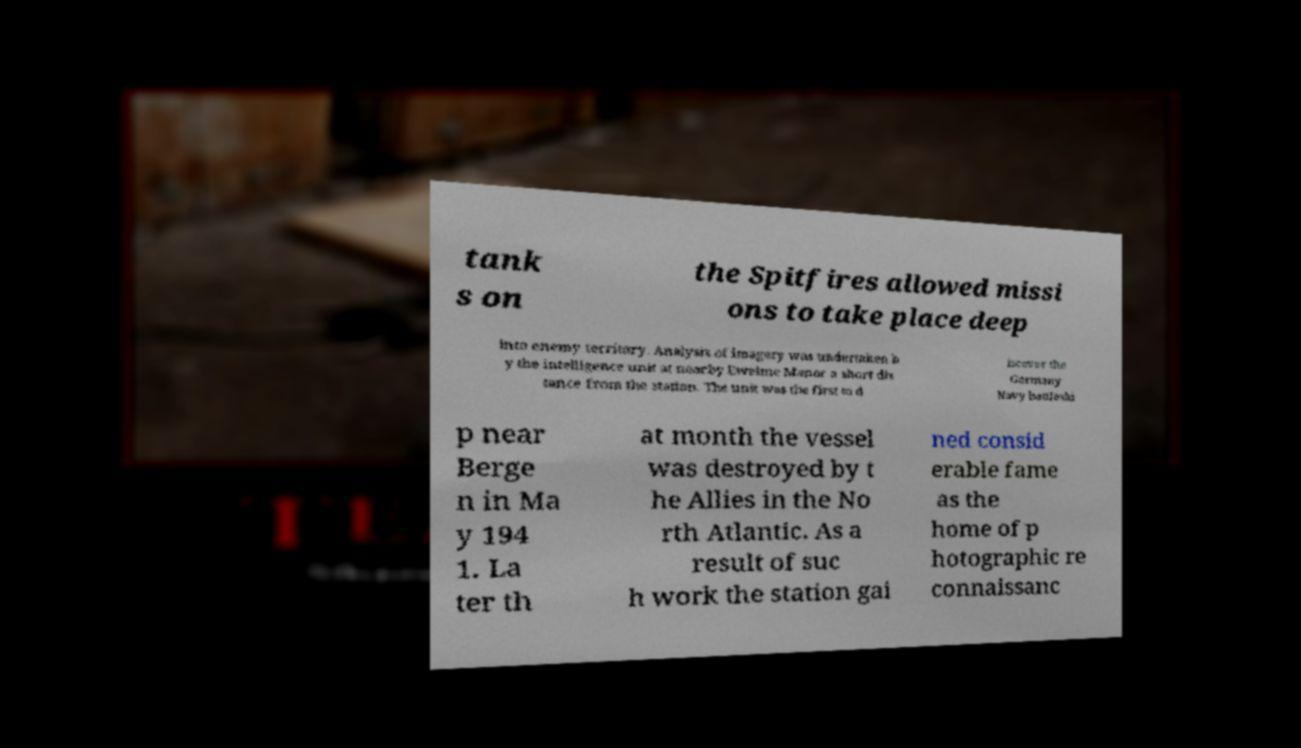Can you read and provide the text displayed in the image?This photo seems to have some interesting text. Can you extract and type it out for me? tank s on the Spitfires allowed missi ons to take place deep into enemy territory. Analysis of imagery was undertaken b y the intelligence unit at nearby Ewelme Manor a short dis tance from the station. The unit was the first to d iscover the Germany Navy battleshi p near Berge n in Ma y 194 1. La ter th at month the vessel was destroyed by t he Allies in the No rth Atlantic. As a result of suc h work the station gai ned consid erable fame as the home of p hotographic re connaissanc 